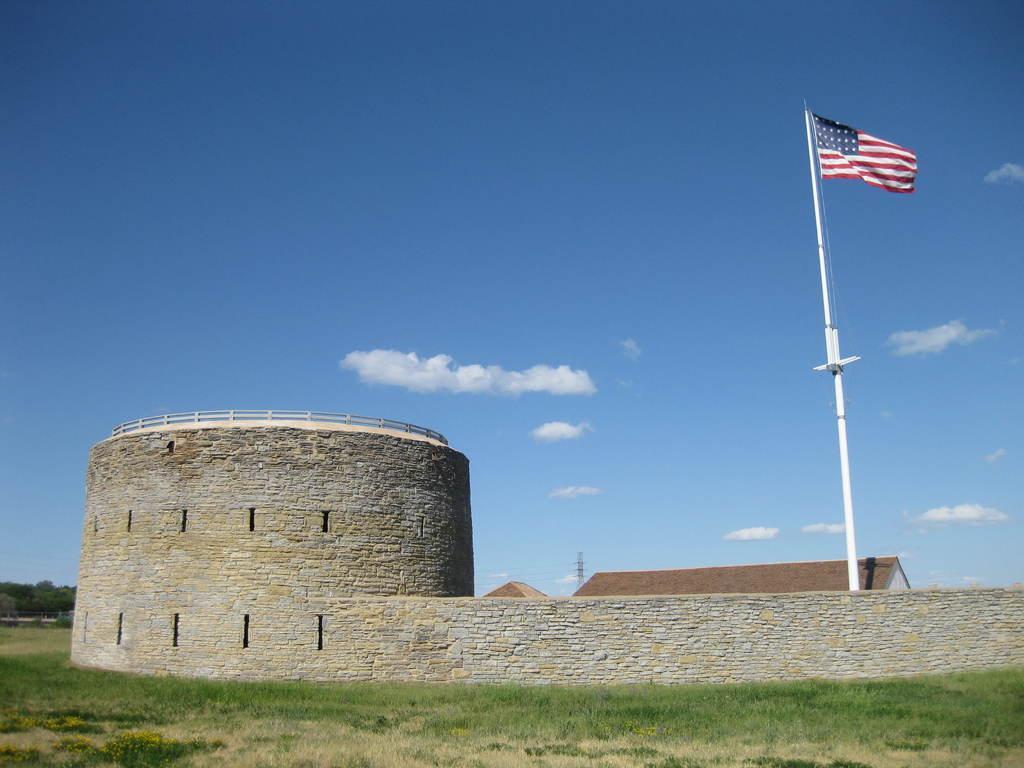Could you give a brief overview of what you see in this image? In the image there is a castle in the front with a flag on the right side and a home behind it on the grassland and above its sky with clouds. 